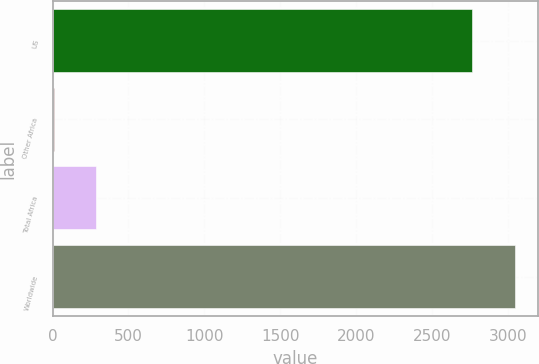Convert chart to OTSL. <chart><loc_0><loc_0><loc_500><loc_500><bar_chart><fcel>US<fcel>Other Africa<fcel>Total Africa<fcel>Worldwide<nl><fcel>2763<fcel>7<fcel>288.9<fcel>3044.9<nl></chart> 